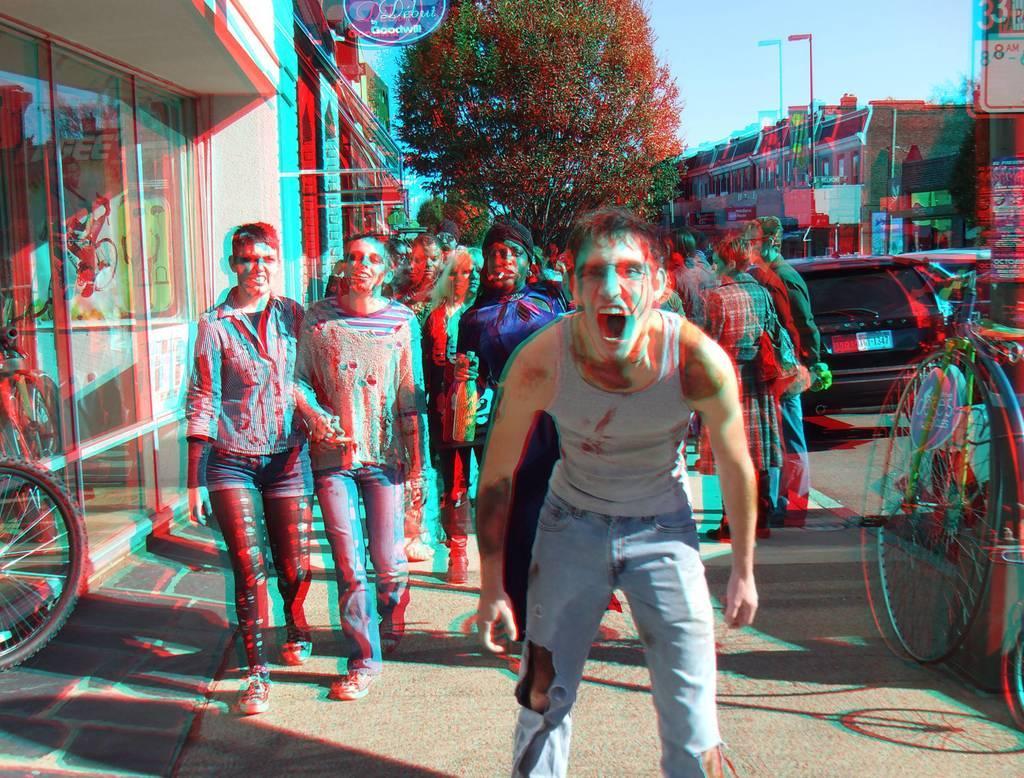Can you describe this image briefly? In this picture we can see group of people and bicycles, in the background we can find few buildings, trees and vehicles. 